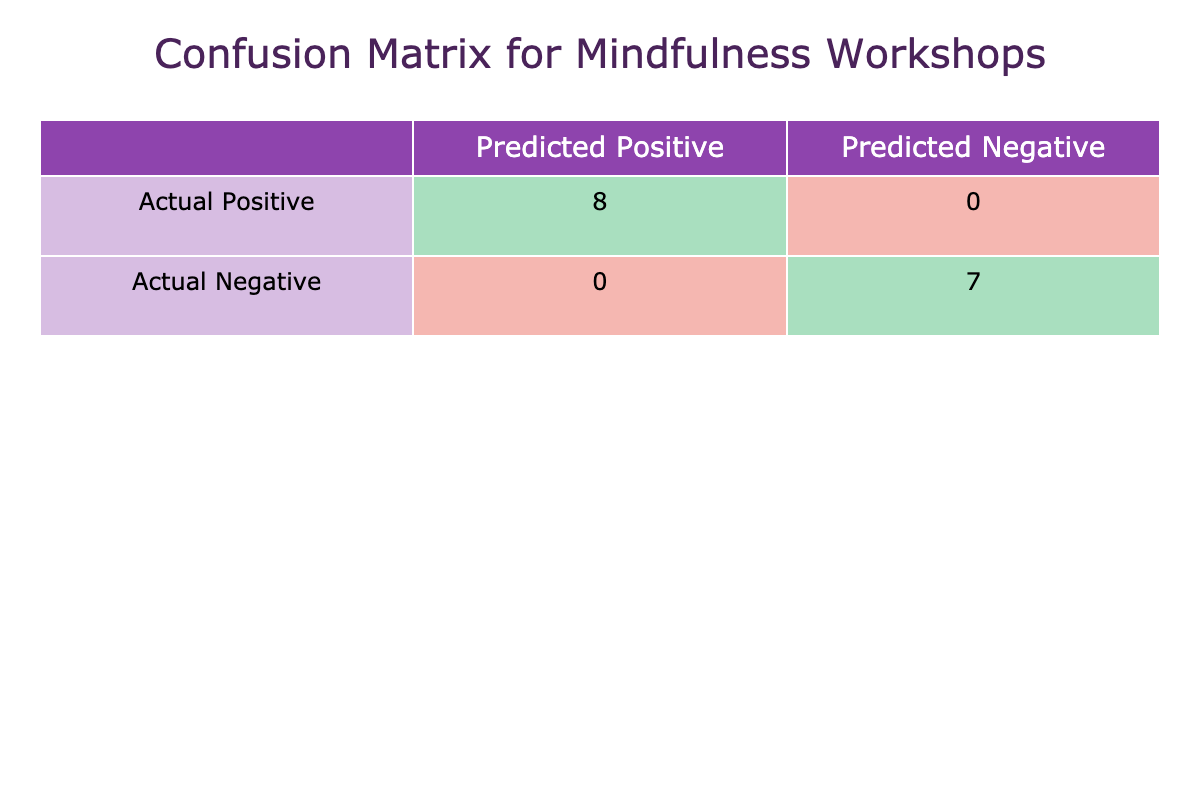What is the number of participants with a successful outcome? There are three participants with a successful outcome who attended workshops: Alice Johnson, Catherine Lee, and Eva Garcia. Therefore, the total is 6.
Answer: 6 How many participants had a negative outcome after attending the workshops? The participants with a negative outcome are Bob Smith, David Wang, Grace Kim, Henry Chen, Jack Thompson, Louis Green, and Oscar Young, leading to a total of 7 participants.
Answer: 7 What is the total number of participants who received a feedback score of 9 or higher? The participants with a feedback score of 9 or higher are Catherine Lee, Eva Garcia, Katherine Brown, and Nancy White. This makes it a total of 4 participants.
Answer: 4 How many participants had both a successful outcome and an attendance rate of 75 or higher? The successful outcomes with an attendance rate of 75 or higher are from Alice Johnson, Catherine Lee, Eva Garcia, Frank Wright, Katherine Brown, and Nancy White, totaling 6 participants.
Answer: 6 What is the total attendance rate of participants who had a successful outcome? To find the total attendance rate of those with a successful outcome, we sum the attendance rates: 90 (Alice Johnson) + 85 (Catherine Lee) + 95 (Eva Garcia) + 80 (Frank Wright) + 75 (Irene Patel) + 88 (Katherine Brown) + 92 (Nancy White) =  515, and there are 7 successful outcomes. Thus, the average attendance rate is 515/7 = approximately 73.57.
Answer: 73.57 Are there any workshops where all participants had a successful outcome? No, there are no workshops listed where all participants had a successful outcome, as individuals with various outcomes attended different workshops.
Answer: No What percentage of the total participants had an attendance rate below 75? The total number of participants is 15, and those with an attendance rate below 75 are: Bob Smith, David Wang, Grace Kim, Henry Chen, Jack Thompson, Louis Green, and Oscar Young, which is 8 participants. Therefore, the percentage is (8/15) * 100 = approximately 53.33%.
Answer: 53.33% Which workshop title had the highest attendance rate? The workshop with the highest attendance rate is the “Silent Retreat” with a percentage of 95.
Answer: Silent Retreat How many successful outcomes correspond to feedback scores of 7 or lower? The successful outcomes where feedback scores are 7 or lower are from Frank Wright and Irene Patel, resulting in a total of 2 outcomes.
Answer: 2 